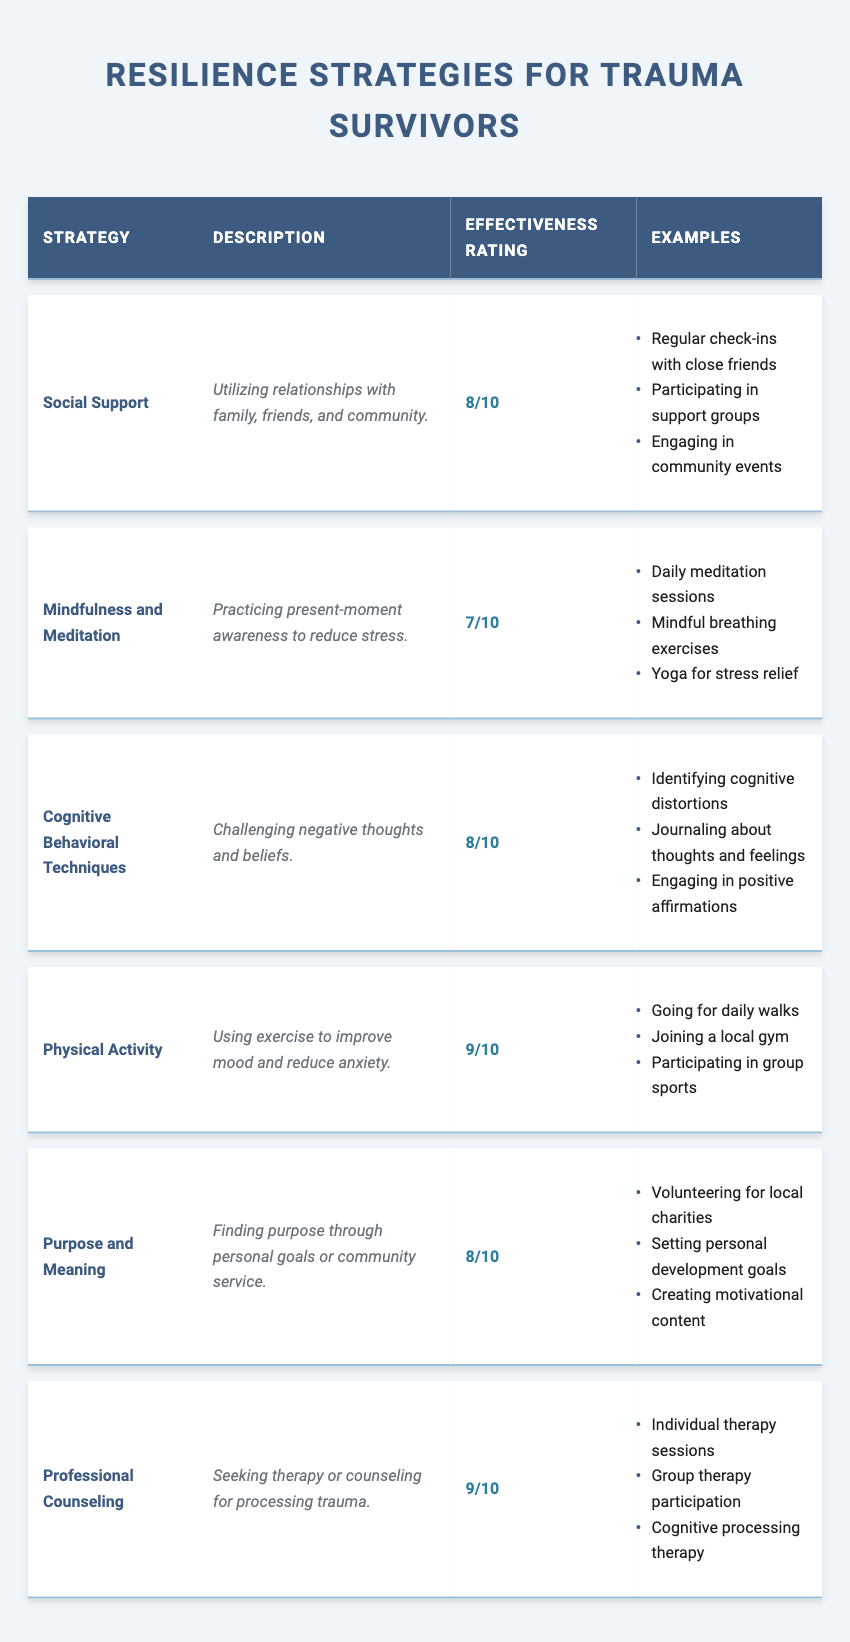What is the effectiveness rating of Physical Activity? The table lists the effectiveness rating for Physical Activity, which is provided in the corresponding column for this strategy. Referring directly to the table, Physical Activity has an effectiveness rating of 9/10.
Answer: 9/10 How many resilience strategies have an effectiveness rating of 8 or higher? To determine this, I will count the number of strategies listed in the table with an effectiveness rating of 8 or more. The strategies with ratings of 8 are: Social Support, Cognitive Behavioral Techniques, Purpose and Meaning. Additionally, Physical Activity and Professional Counseling have ratings of 9. This gives a total of 5 strategies (Social Support, Cognitive Behavioral Techniques, Purpose and Meaning, Physical Activity, Professional Counseling) with ratings of 8 or higher.
Answer: 5 Does Mindfulness and Meditation have a higher effectiveness rating than Purpose and Meaning? I will compare the effectiveness ratings presented in the table. Mindfulness and Meditation has an effectiveness rating of 7/10, while Purpose and Meaning has a rating of 8/10. Since 7 is less than 8, the statement is false.
Answer: No Which strategy has the highest effectiveness rating? The question requires identifying the strategy with the highest effectiveness rating by inspecting the ratings listed in the table. Physical Activity and Professional Counseling both have the highest effectiveness rating of 9/10. Thus, either can be considered as having the highest rating.
Answer: Physical Activity and Professional Counseling What are two examples of strategies that involve seeking help from others? To find examples of strategies that involve seeking help from others, I will refer to the descriptions and examples in the table. Social Support specifically mentions utilizing relationships with family and friends, and Professional Counseling involves seeking therapy or counseling. Both strategies emphasize the involvement of others for support.
Answer: Social Support and Professional Counseling If I wanted to try an individual strategy from the table to improve my resilience today, which two strategies would you recommend based on their effectiveness ratings? I will look for strategies that have high effectiveness ratings. Physical Activity and Professional Counseling have the highest ratings of 9/10, making them the strongest recommendations for someone seeking to improve resilience.
Answer: Physical Activity and Professional Counseling 